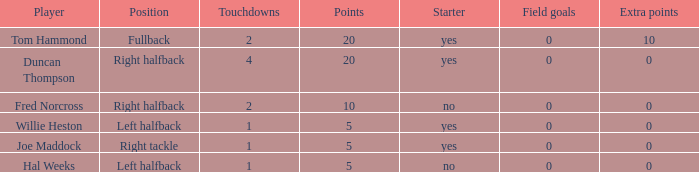What is the highest field goals when there were more than 1 touchdown and 0 extra points? 0.0. 